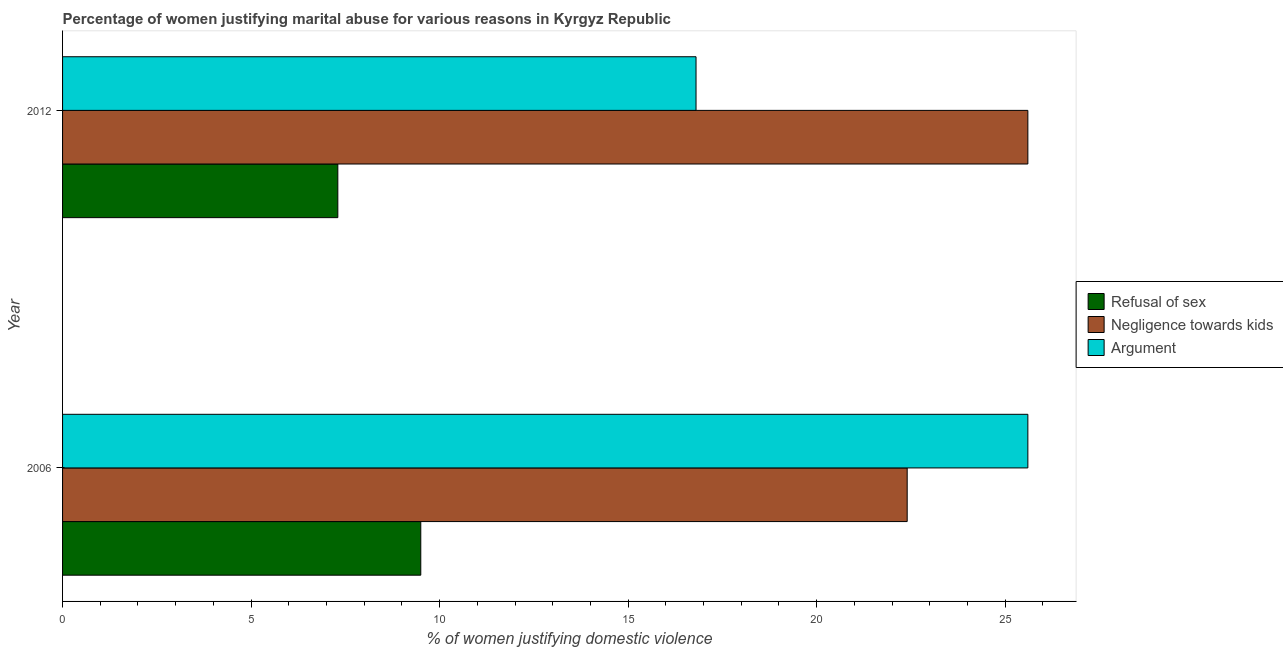How many different coloured bars are there?
Keep it short and to the point. 3. How many groups of bars are there?
Provide a succinct answer. 2. How many bars are there on the 1st tick from the top?
Offer a terse response. 3. What is the label of the 1st group of bars from the top?
Your response must be concise. 2012. In how many cases, is the number of bars for a given year not equal to the number of legend labels?
Give a very brief answer. 0. What is the percentage of women justifying domestic violence due to negligence towards kids in 2012?
Make the answer very short. 25.6. Across all years, what is the maximum percentage of women justifying domestic violence due to arguments?
Make the answer very short. 25.6. Across all years, what is the minimum percentage of women justifying domestic violence due to negligence towards kids?
Offer a terse response. 22.4. What is the total percentage of women justifying domestic violence due to arguments in the graph?
Give a very brief answer. 42.4. What is the difference between the percentage of women justifying domestic violence due to negligence towards kids in 2006 and the percentage of women justifying domestic violence due to refusal of sex in 2012?
Offer a terse response. 15.1. What is the average percentage of women justifying domestic violence due to arguments per year?
Your answer should be compact. 21.2. In the year 2012, what is the difference between the percentage of women justifying domestic violence due to arguments and percentage of women justifying domestic violence due to negligence towards kids?
Provide a succinct answer. -8.8. What is the ratio of the percentage of women justifying domestic violence due to arguments in 2006 to that in 2012?
Your answer should be very brief. 1.52. In how many years, is the percentage of women justifying domestic violence due to arguments greater than the average percentage of women justifying domestic violence due to arguments taken over all years?
Provide a succinct answer. 1. What does the 2nd bar from the top in 2012 represents?
Your answer should be very brief. Negligence towards kids. What does the 1st bar from the bottom in 2006 represents?
Your answer should be very brief. Refusal of sex. Is it the case that in every year, the sum of the percentage of women justifying domestic violence due to refusal of sex and percentage of women justifying domestic violence due to negligence towards kids is greater than the percentage of women justifying domestic violence due to arguments?
Your answer should be very brief. Yes. How many bars are there?
Offer a terse response. 6. Are all the bars in the graph horizontal?
Offer a very short reply. Yes. Does the graph contain grids?
Your answer should be compact. No. How many legend labels are there?
Provide a short and direct response. 3. How are the legend labels stacked?
Give a very brief answer. Vertical. What is the title of the graph?
Provide a succinct answer. Percentage of women justifying marital abuse for various reasons in Kyrgyz Republic. Does "Male employers" appear as one of the legend labels in the graph?
Make the answer very short. No. What is the label or title of the X-axis?
Provide a succinct answer. % of women justifying domestic violence. What is the label or title of the Y-axis?
Your response must be concise. Year. What is the % of women justifying domestic violence of Negligence towards kids in 2006?
Provide a short and direct response. 22.4. What is the % of women justifying domestic violence of Argument in 2006?
Ensure brevity in your answer.  25.6. What is the % of women justifying domestic violence of Refusal of sex in 2012?
Provide a succinct answer. 7.3. What is the % of women justifying domestic violence in Negligence towards kids in 2012?
Provide a succinct answer. 25.6. Across all years, what is the maximum % of women justifying domestic violence in Refusal of sex?
Keep it short and to the point. 9.5. Across all years, what is the maximum % of women justifying domestic violence in Negligence towards kids?
Make the answer very short. 25.6. Across all years, what is the maximum % of women justifying domestic violence in Argument?
Keep it short and to the point. 25.6. Across all years, what is the minimum % of women justifying domestic violence in Negligence towards kids?
Your answer should be compact. 22.4. Across all years, what is the minimum % of women justifying domestic violence of Argument?
Your response must be concise. 16.8. What is the total % of women justifying domestic violence in Refusal of sex in the graph?
Your answer should be very brief. 16.8. What is the total % of women justifying domestic violence in Argument in the graph?
Offer a terse response. 42.4. What is the difference between the % of women justifying domestic violence in Argument in 2006 and that in 2012?
Give a very brief answer. 8.8. What is the difference between the % of women justifying domestic violence of Refusal of sex in 2006 and the % of women justifying domestic violence of Negligence towards kids in 2012?
Provide a short and direct response. -16.1. What is the difference between the % of women justifying domestic violence in Negligence towards kids in 2006 and the % of women justifying domestic violence in Argument in 2012?
Offer a very short reply. 5.6. What is the average % of women justifying domestic violence in Argument per year?
Offer a very short reply. 21.2. In the year 2006, what is the difference between the % of women justifying domestic violence of Refusal of sex and % of women justifying domestic violence of Negligence towards kids?
Your answer should be compact. -12.9. In the year 2006, what is the difference between the % of women justifying domestic violence of Refusal of sex and % of women justifying domestic violence of Argument?
Provide a short and direct response. -16.1. In the year 2006, what is the difference between the % of women justifying domestic violence in Negligence towards kids and % of women justifying domestic violence in Argument?
Provide a short and direct response. -3.2. In the year 2012, what is the difference between the % of women justifying domestic violence of Refusal of sex and % of women justifying domestic violence of Negligence towards kids?
Offer a terse response. -18.3. In the year 2012, what is the difference between the % of women justifying domestic violence of Refusal of sex and % of women justifying domestic violence of Argument?
Your answer should be very brief. -9.5. In the year 2012, what is the difference between the % of women justifying domestic violence of Negligence towards kids and % of women justifying domestic violence of Argument?
Offer a very short reply. 8.8. What is the ratio of the % of women justifying domestic violence in Refusal of sex in 2006 to that in 2012?
Give a very brief answer. 1.3. What is the ratio of the % of women justifying domestic violence of Argument in 2006 to that in 2012?
Offer a very short reply. 1.52. What is the difference between the highest and the second highest % of women justifying domestic violence in Negligence towards kids?
Your answer should be compact. 3.2. What is the difference between the highest and the second highest % of women justifying domestic violence in Argument?
Provide a succinct answer. 8.8. What is the difference between the highest and the lowest % of women justifying domestic violence in Refusal of sex?
Your answer should be very brief. 2.2. What is the difference between the highest and the lowest % of women justifying domestic violence in Negligence towards kids?
Make the answer very short. 3.2. What is the difference between the highest and the lowest % of women justifying domestic violence in Argument?
Keep it short and to the point. 8.8. 